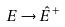Convert formula to latex. <formula><loc_0><loc_0><loc_500><loc_500>E \rightarrow \hat { E } ^ { + }</formula> 